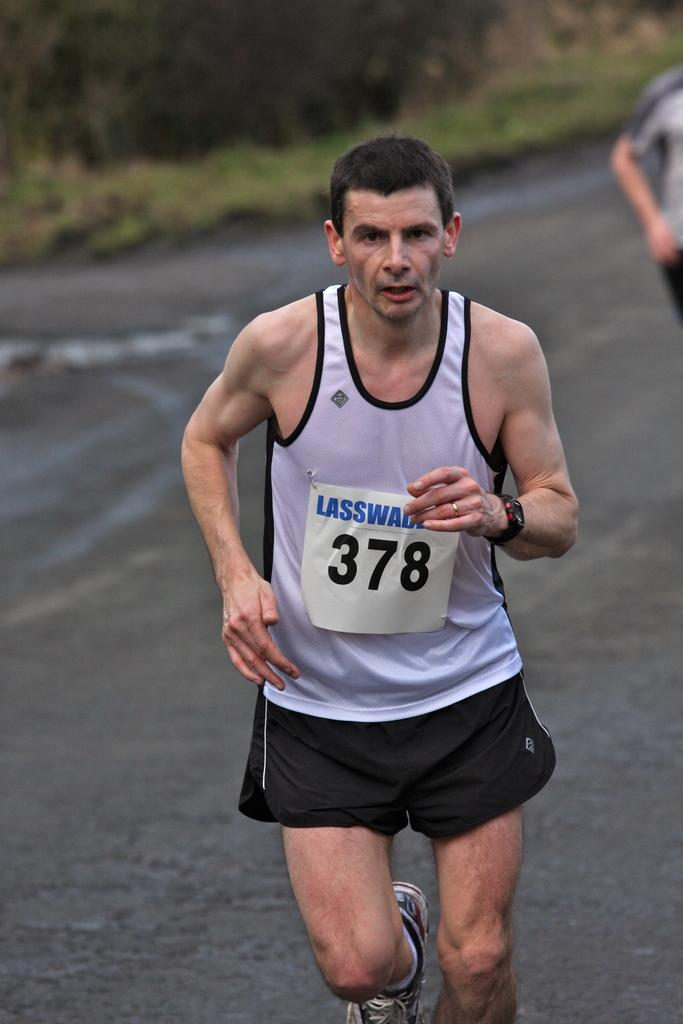<image>
Provide a brief description of the given image. A runner is wearing a tag that says Lasswade 378. 